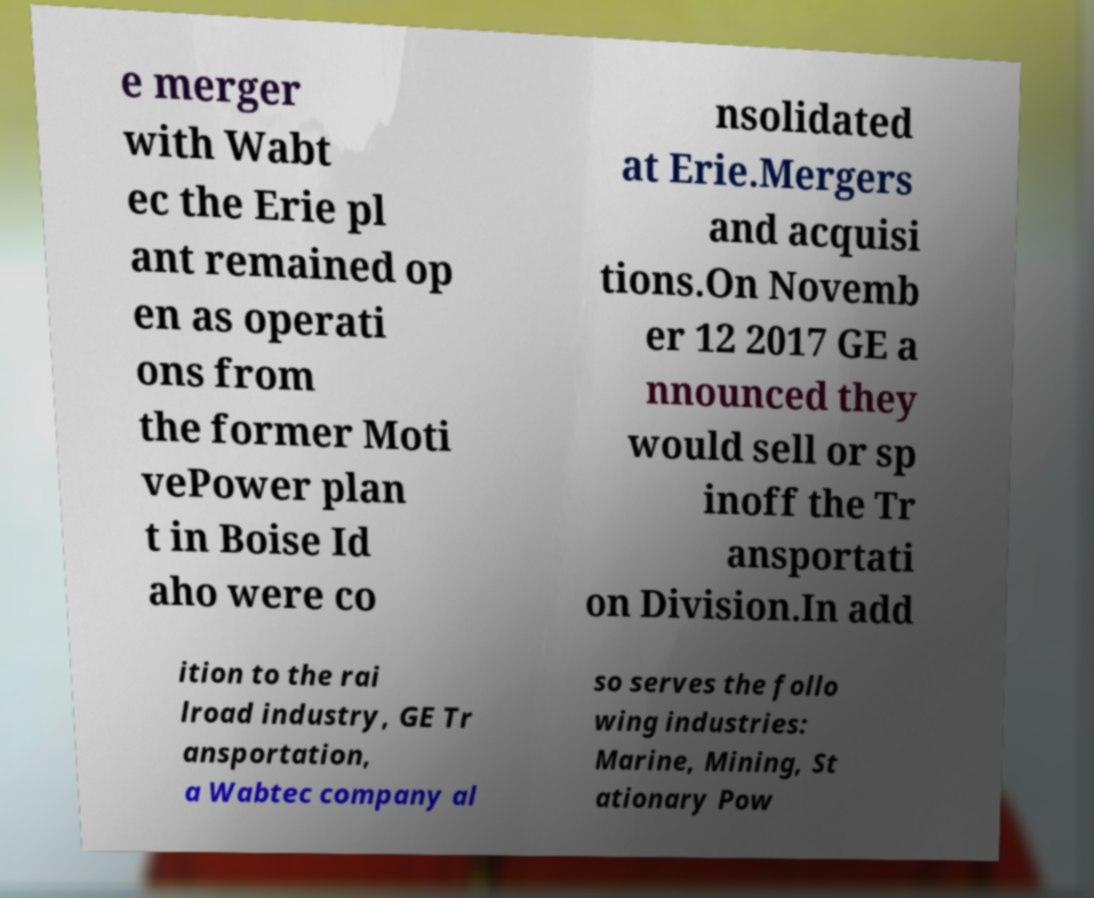Could you extract and type out the text from this image? e merger with Wabt ec the Erie pl ant remained op en as operati ons from the former Moti vePower plan t in Boise Id aho were co nsolidated at Erie.Mergers and acquisi tions.On Novemb er 12 2017 GE a nnounced they would sell or sp inoff the Tr ansportati on Division.In add ition to the rai lroad industry, GE Tr ansportation, a Wabtec company al so serves the follo wing industries: Marine, Mining, St ationary Pow 